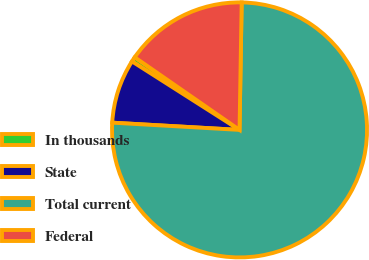<chart> <loc_0><loc_0><loc_500><loc_500><pie_chart><fcel>In thousands<fcel>State<fcel>Total current<fcel>Federal<nl><fcel>0.62%<fcel>8.12%<fcel>75.63%<fcel>15.62%<nl></chart> 